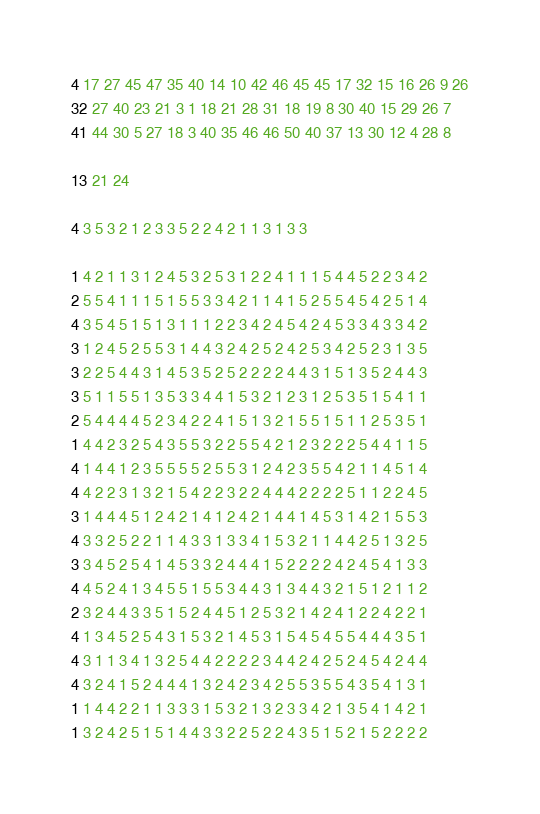Convert code to text. <code><loc_0><loc_0><loc_500><loc_500><_Matlab_>4 17 27 45 47 35 40 14 10 42 46 45 45 17 32 15 16 26 9 26
32 27 40 23 21 3 1 18 21 28 31 18 19 8 30 40 15 29 26 7
41 44 30 5 27 18 3 40 35 46 46 50 40 37 13 30 12 4 28 8

13 21 24

4 3 5 3 2 1 2 3 3 5 2 2 4 2 1 1 3 1 3 3

1 4 2 1 1 3 1 2 4 5 3 2 5 3 1 2 2 4 1 1 1 5 4 4 5 2 2 3 4 2
2 5 5 4 1 1 1 5 1 5 5 3 3 4 2 1 1 4 1 5 2 5 5 4 5 4 2 5 1 4
4 3 5 4 5 1 5 1 3 1 1 1 2 2 3 4 2 4 5 4 2 4 5 3 3 4 3 3 4 2
3 1 2 4 5 2 5 5 3 1 4 4 3 2 4 2 5 2 4 2 5 3 4 2 5 2 3 1 3 5
3 2 2 5 4 4 3 1 4 5 3 5 2 5 2 2 2 2 4 4 3 1 5 1 3 5 2 4 4 3
3 5 1 1 5 5 1 3 5 3 3 4 4 1 5 3 2 1 2 3 1 2 5 3 5 1 5 4 1 1
2 5 4 4 4 4 5 2 3 4 2 2 4 1 5 1 3 2 1 5 5 1 5 1 1 2 5 3 5 1
1 4 4 2 3 2 5 4 3 5 5 3 2 2 5 5 4 2 1 2 3 2 2 2 5 4 4 1 1 5
4 1 4 4 1 2 3 5 5 5 5 2 5 5 3 1 2 4 2 3 5 5 4 2 1 1 4 5 1 4
4 4 2 2 3 1 3 2 1 5 4 2 2 3 2 2 4 4 4 2 2 2 2 5 1 1 2 2 4 5
3 1 4 4 4 5 1 2 4 2 1 4 1 2 4 2 1 4 4 1 4 5 3 1 4 2 1 5 5 3
4 3 3 2 5 2 2 1 1 4 3 3 1 3 3 4 1 5 3 2 1 1 4 4 2 5 1 3 2 5
3 3 4 5 2 5 4 1 4 5 3 3 2 4 4 4 1 5 2 2 2 2 4 2 4 5 4 1 3 3
4 4 5 2 4 1 3 4 5 5 1 5 5 3 4 4 3 1 3 4 4 3 2 1 5 1 2 1 1 2
2 3 2 4 4 3 3 5 1 5 2 4 4 5 1 2 5 3 2 1 4 2 4 1 2 2 4 2 2 1
4 1 3 4 5 2 5 4 3 1 5 3 2 1 4 5 3 1 5 4 5 4 5 5 4 4 4 3 5 1
4 3 1 1 3 4 1 3 2 5 4 4 2 2 2 2 3 4 4 2 4 2 5 2 4 5 4 2 4 4
4 3 2 4 1 5 2 4 4 4 1 3 2 4 2 3 4 2 5 5 3 5 5 4 3 5 4 1 3 1
1 1 4 4 2 2 1 1 3 3 3 1 5 3 2 1 3 2 3 3 4 2 1 3 5 4 1 4 2 1
1 3 2 4 2 5 1 5 1 4 4 3 3 2 2 5 2 2 4 3 5 1 5 2 1 5 2 2 2 2
</code> 